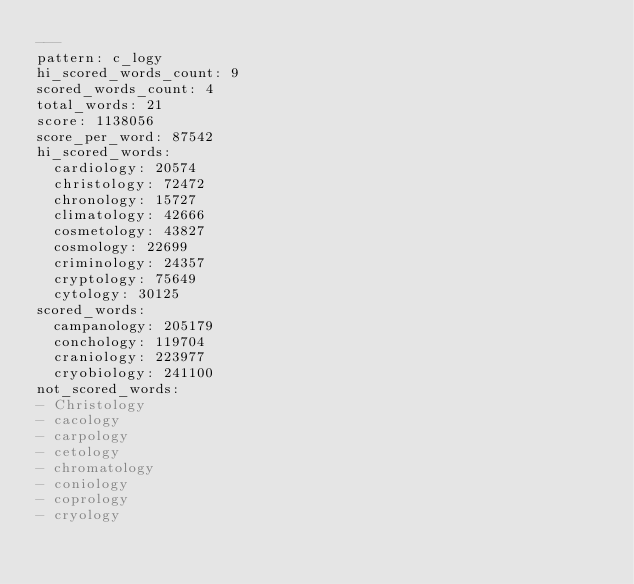<code> <loc_0><loc_0><loc_500><loc_500><_YAML_>---
pattern: c_logy
hi_scored_words_count: 9
scored_words_count: 4
total_words: 21
score: 1138056
score_per_word: 87542
hi_scored_words:
  cardiology: 20574
  christology: 72472
  chronology: 15727
  climatology: 42666
  cosmetology: 43827
  cosmology: 22699
  criminology: 24357
  cryptology: 75649
  cytology: 30125
scored_words:
  campanology: 205179
  conchology: 119704
  craniology: 223977
  cryobiology: 241100
not_scored_words:
- Christology
- cacology
- carpology
- cetology
- chromatology
- coniology
- coprology
- cryology
</code> 